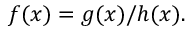<formula> <loc_0><loc_0><loc_500><loc_500>f ( x ) = g ( x ) / h ( x ) .</formula> 